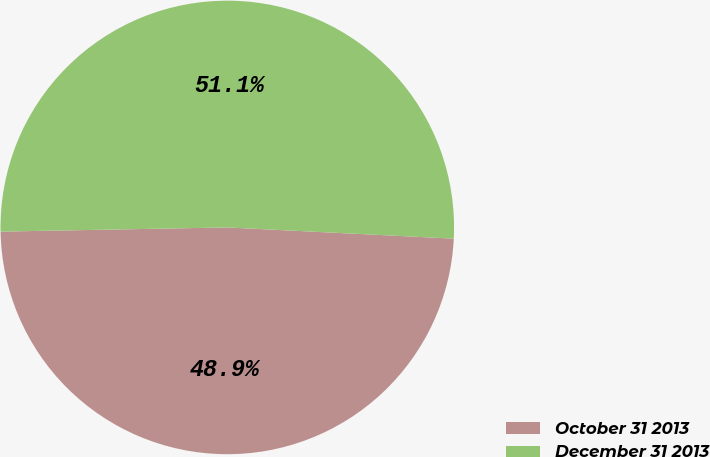Convert chart to OTSL. <chart><loc_0><loc_0><loc_500><loc_500><pie_chart><fcel>October 31 2013<fcel>December 31 2013<nl><fcel>48.92%<fcel>51.08%<nl></chart> 